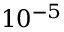Convert formula to latex. <formula><loc_0><loc_0><loc_500><loc_500>1 0 ^ { - 5 }</formula> 